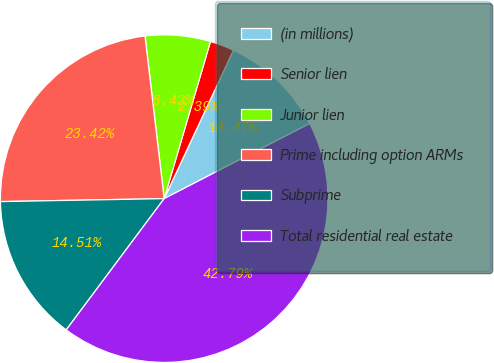Convert chart. <chart><loc_0><loc_0><loc_500><loc_500><pie_chart><fcel>(in millions)<fcel>Senior lien<fcel>Junior lien<fcel>Prime including option ARMs<fcel>Subprime<fcel>Total residential real estate<nl><fcel>10.47%<fcel>2.39%<fcel>6.43%<fcel>23.42%<fcel>14.51%<fcel>42.79%<nl></chart> 